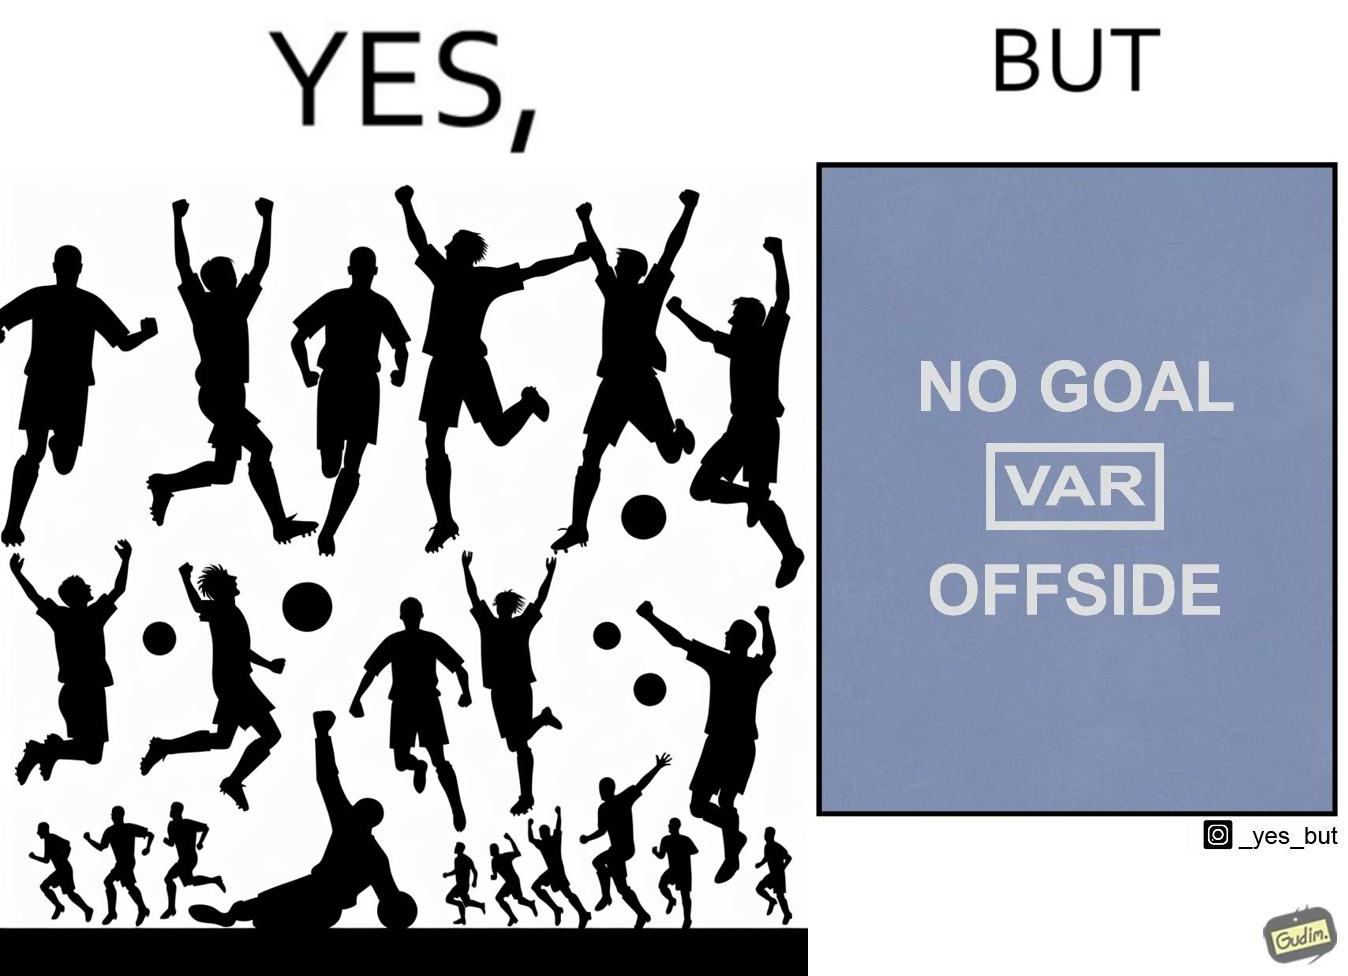Describe the contrast between the left and right parts of this image. In the left part of the image: football players celebrating, probably due a goal their team has scored. In the right part of the image: A sign of "No goal - Offside". 